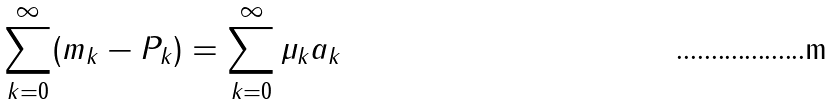Convert formula to latex. <formula><loc_0><loc_0><loc_500><loc_500>\sum _ { k = 0 } ^ { \infty } ( m _ { k } - P _ { k } ) = \sum _ { k = 0 } ^ { \infty } \mu _ { k } a _ { k }</formula> 